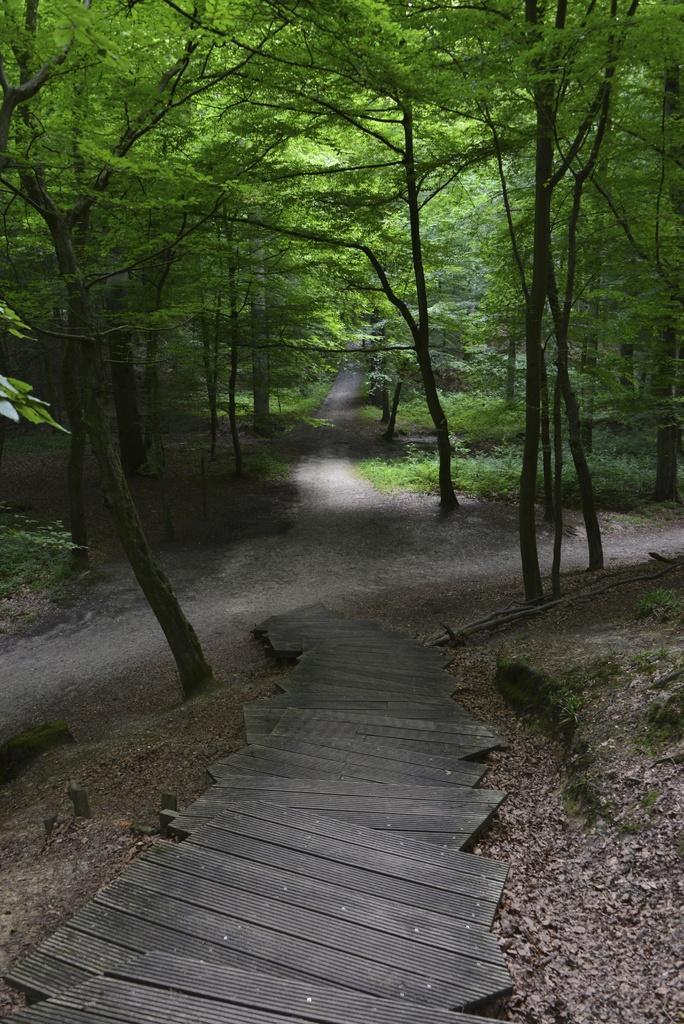Describe this image in one or two sentences. In this picture we can see wooden planks, road, plants, dried leaves on the ground and in the background we can see trees. 